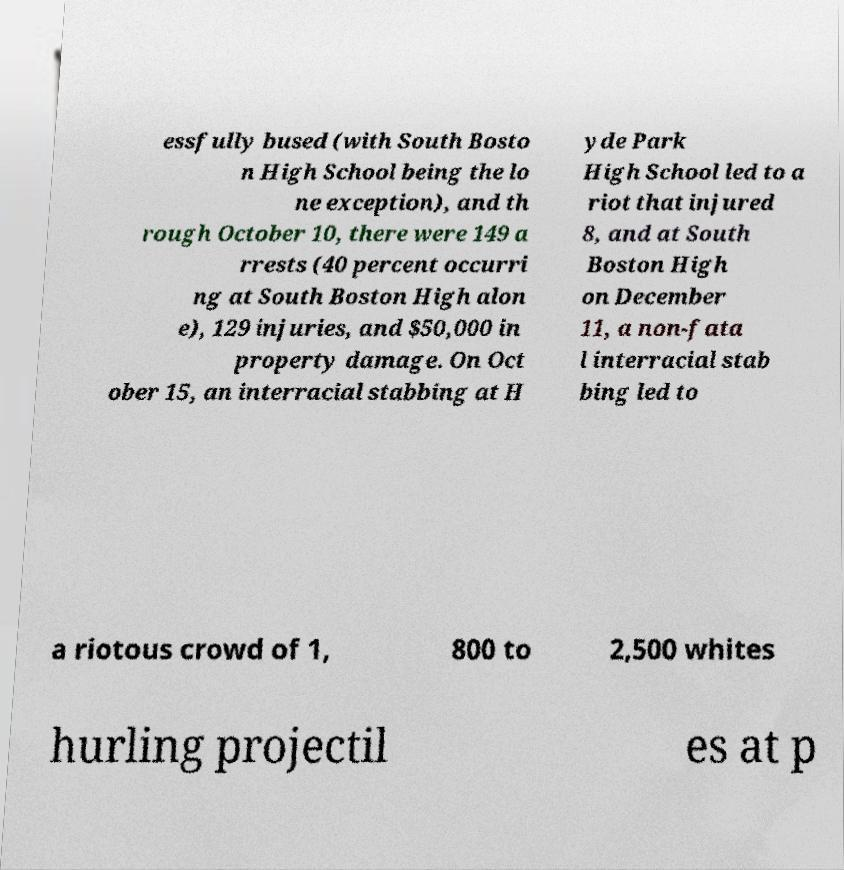Can you accurately transcribe the text from the provided image for me? essfully bused (with South Bosto n High School being the lo ne exception), and th rough October 10, there were 149 a rrests (40 percent occurri ng at South Boston High alon e), 129 injuries, and $50,000 in property damage. On Oct ober 15, an interracial stabbing at H yde Park High School led to a riot that injured 8, and at South Boston High on December 11, a non-fata l interracial stab bing led to a riotous crowd of 1, 800 to 2,500 whites hurling projectil es at p 